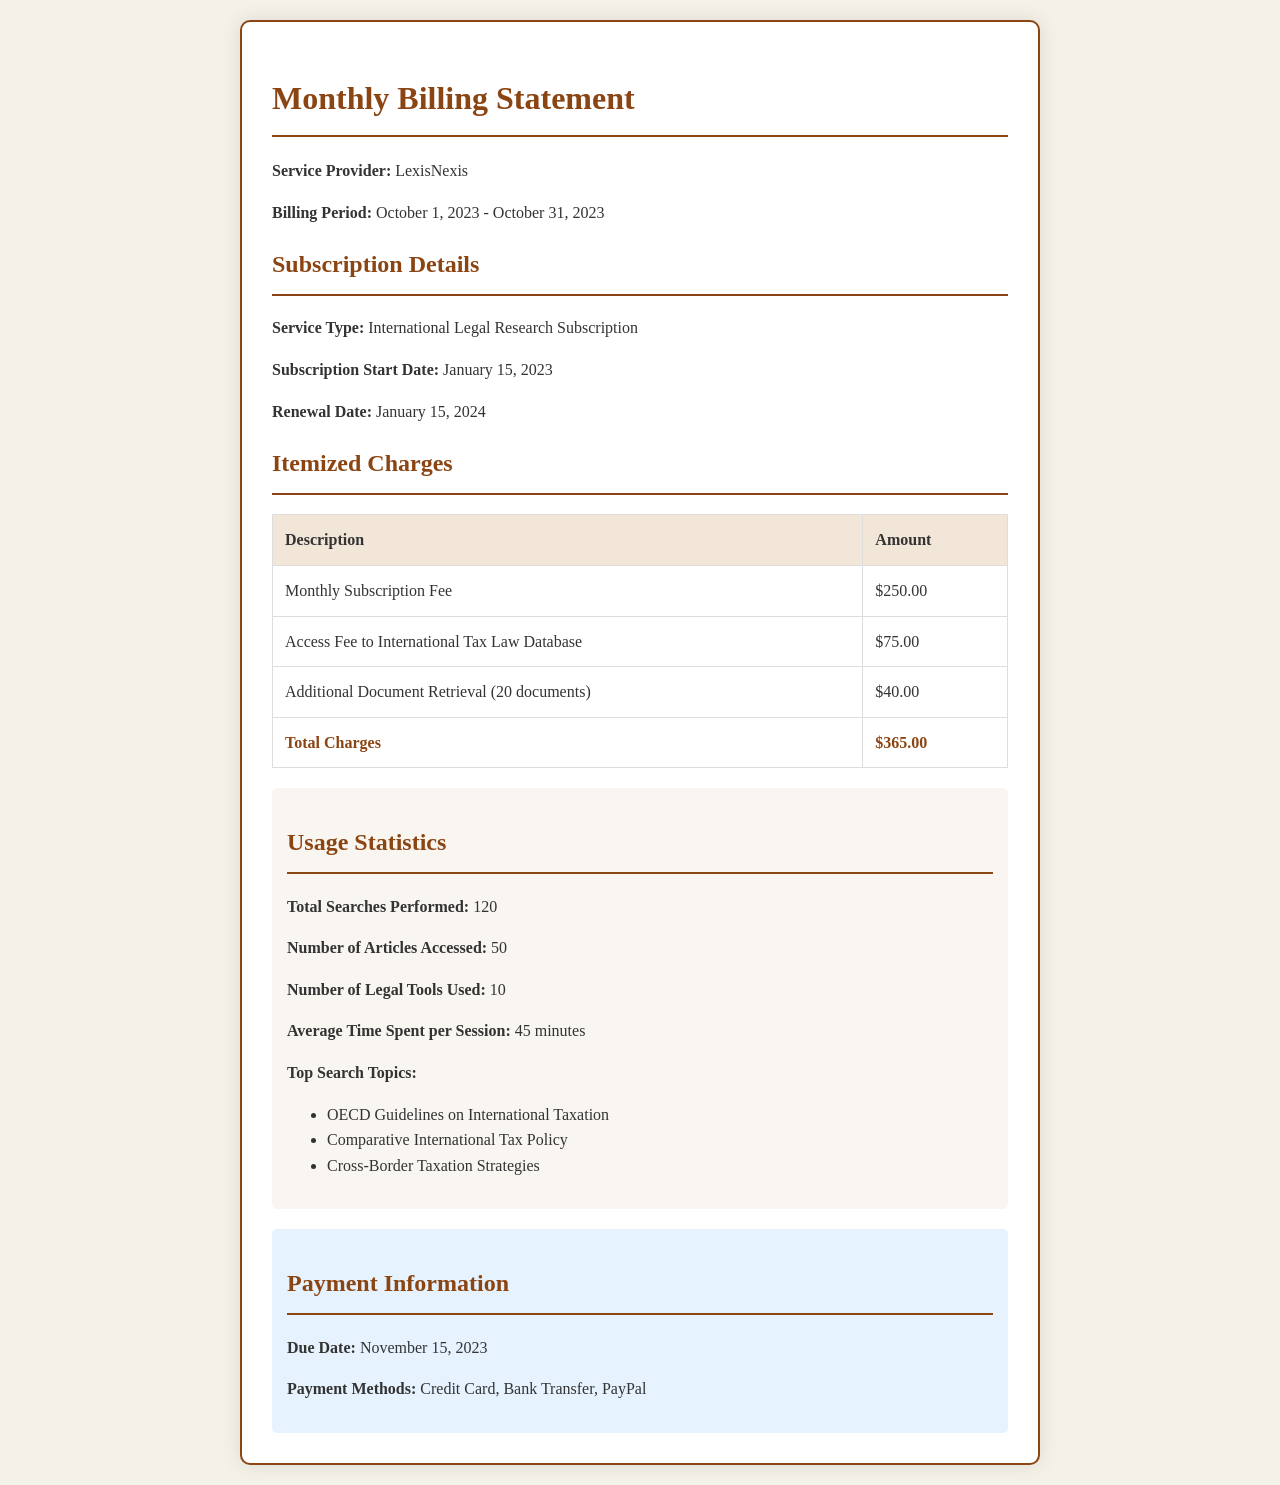What is the service provider's name? The service provider's name is directly mentioned at the start of the billing statement.
Answer: LexisNexis What is the total amount charged for this billing period? The total amount charged is indicated in the itemized charges table.
Answer: $365.00 What is the billing period mentioned in the document? The billing period is specified in the introductory section of the document.
Answer: October 1, 2023 - October 31, 2023 How many total searches were performed? The total searches performed is listed under usage statistics.
Answer: 120 What is the due date for the payment? The due date is provided under the payment information section.
Answer: November 15, 2023 How much is the monthly subscription fee? The monthly subscription fee can be found in the itemized charges table.
Answer: $250.00 What is the average time spent per session? The average time spent per session is mentioned in the usage statistics.
Answer: 45 minutes What is the renewal date of the subscription? The renewal date is clearly stated in the subscription details section.
Answer: January 15, 2024 How many articles were accessed? The number of articles accessed is detailed in the usage statistics.
Answer: 50 